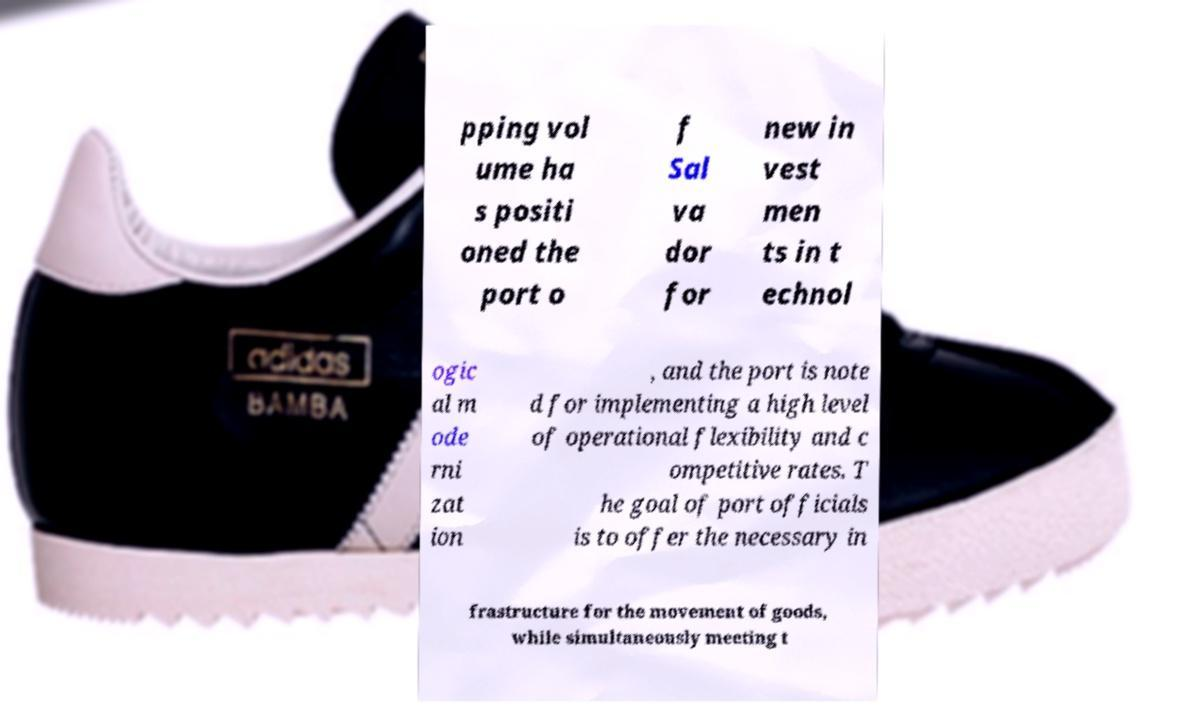Please read and relay the text visible in this image. What does it say? pping vol ume ha s positi oned the port o f Sal va dor for new in vest men ts in t echnol ogic al m ode rni zat ion , and the port is note d for implementing a high level of operational flexibility and c ompetitive rates. T he goal of port officials is to offer the necessary in frastructure for the movement of goods, while simultaneously meeting t 